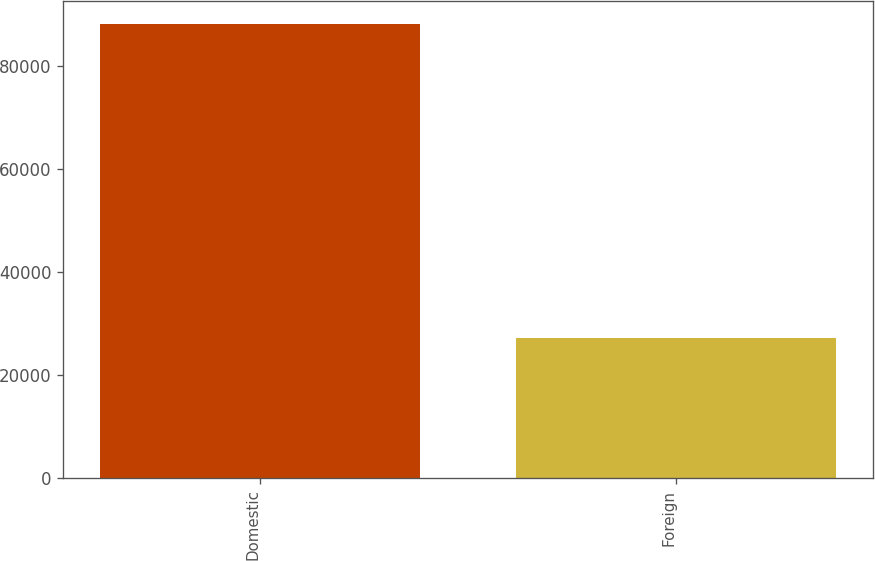Convert chart. <chart><loc_0><loc_0><loc_500><loc_500><bar_chart><fcel>Domestic<fcel>Foreign<nl><fcel>88065<fcel>27103<nl></chart> 